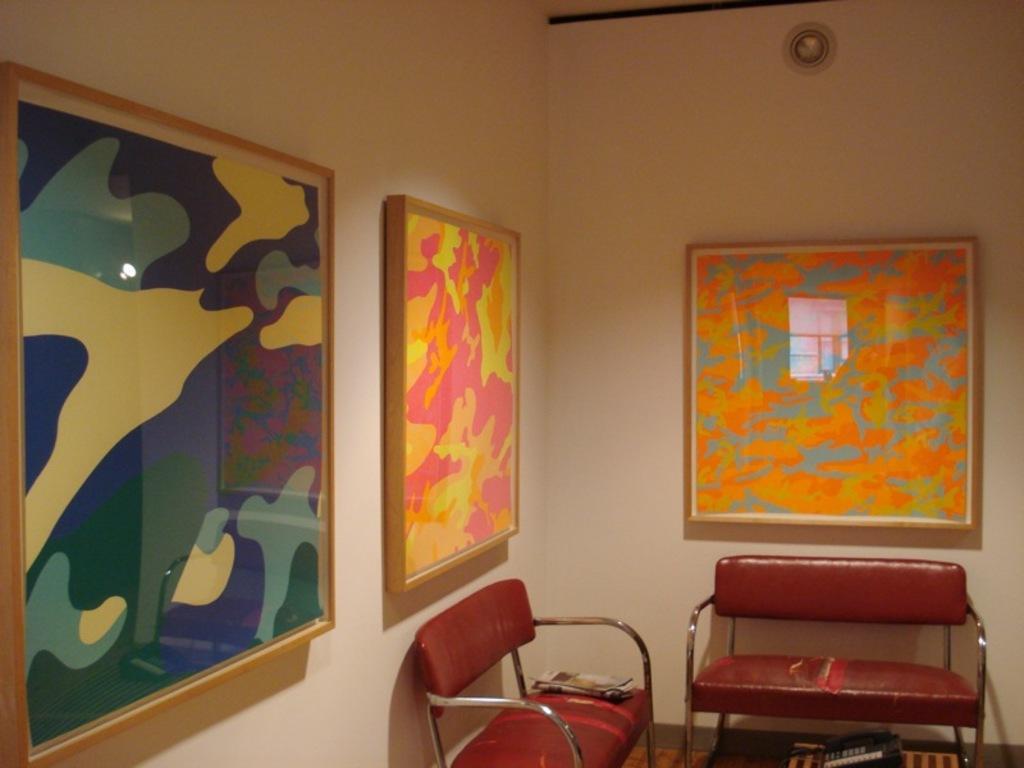Could you give a brief overview of what you see in this image? There are two sofas in this room and some photo frames attached to the wall here. 